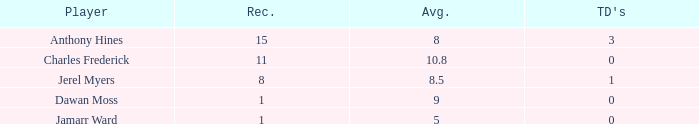What is the average number of TDs when the yards are less than 119, the AVG is larger than 5, and Jamarr Ward is a player? None. 